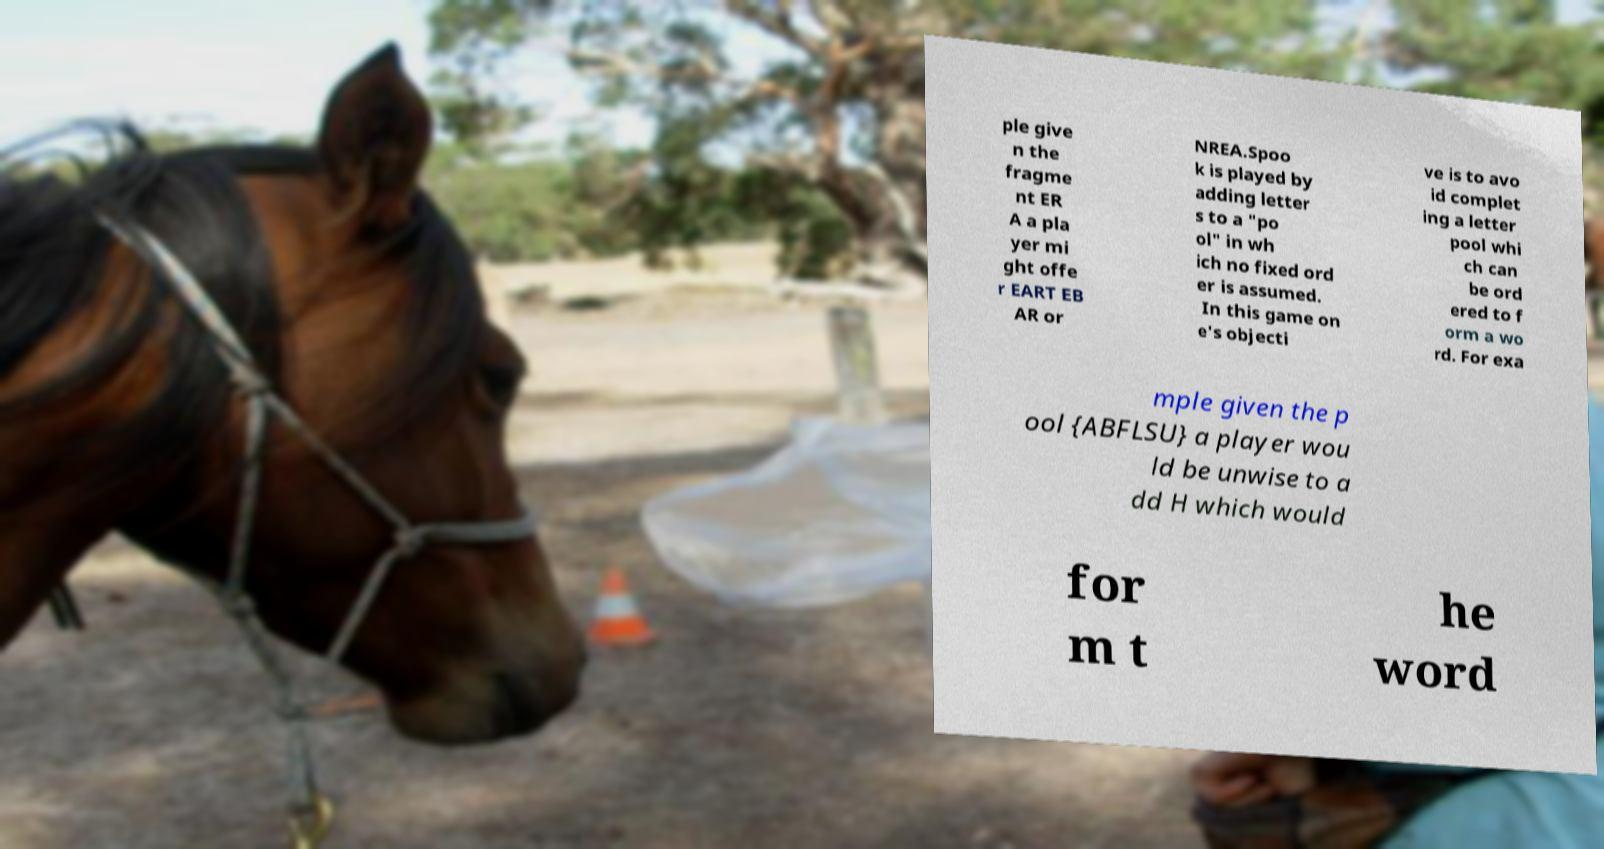Please read and relay the text visible in this image. What does it say? ple give n the fragme nt ER A a pla yer mi ght offe r EART EB AR or NREA.Spoo k is played by adding letter s to a "po ol" in wh ich no fixed ord er is assumed. In this game on e's objecti ve is to avo id complet ing a letter pool whi ch can be ord ered to f orm a wo rd. For exa mple given the p ool {ABFLSU} a player wou ld be unwise to a dd H which would for m t he word 